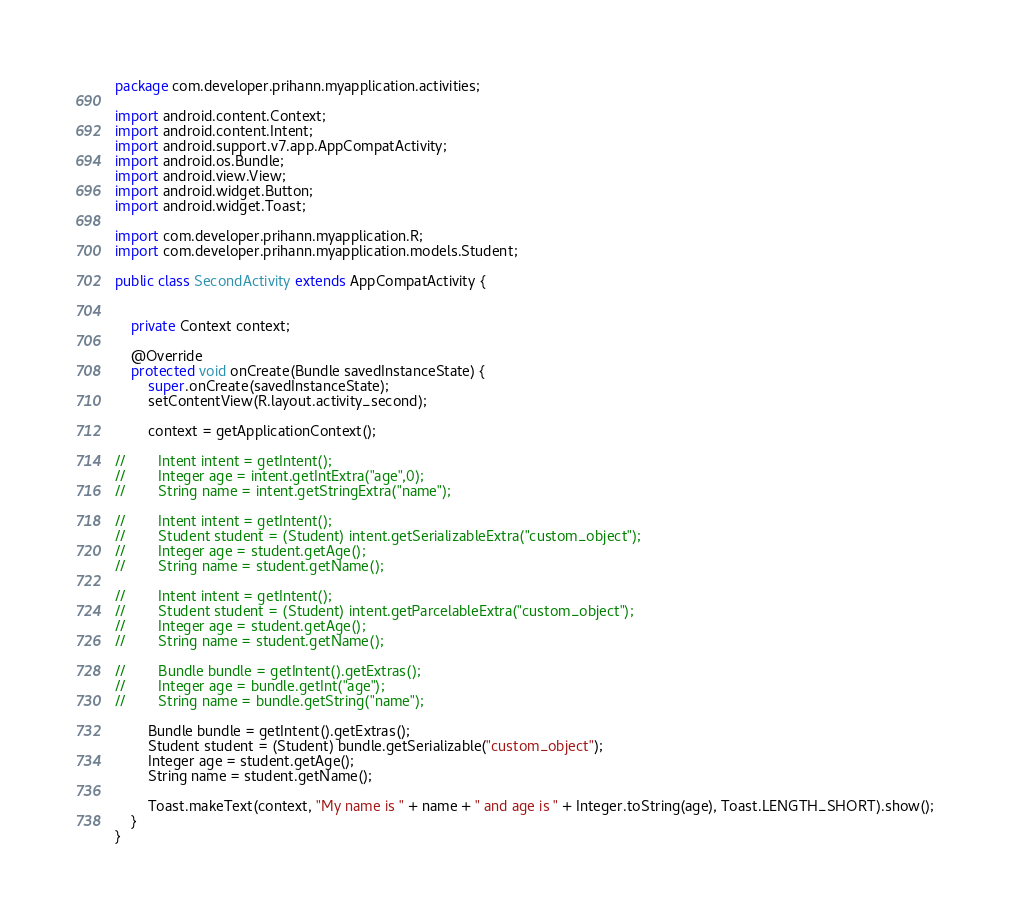Convert code to text. <code><loc_0><loc_0><loc_500><loc_500><_Java_>package com.developer.prihann.myapplication.activities;

import android.content.Context;
import android.content.Intent;
import android.support.v7.app.AppCompatActivity;
import android.os.Bundle;
import android.view.View;
import android.widget.Button;
import android.widget.Toast;

import com.developer.prihann.myapplication.R;
import com.developer.prihann.myapplication.models.Student;

public class SecondActivity extends AppCompatActivity {


    private Context context;

    @Override
    protected void onCreate(Bundle savedInstanceState) {
        super.onCreate(savedInstanceState);
        setContentView(R.layout.activity_second);

        context = getApplicationContext();

//        Intent intent = getIntent();
//        Integer age = intent.getIntExtra("age",0);
//        String name = intent.getStringExtra("name");

//        Intent intent = getIntent();
//        Student student = (Student) intent.getSerializableExtra("custom_object");
//        Integer age = student.getAge();
//        String name = student.getName();

//        Intent intent = getIntent();
//        Student student = (Student) intent.getParcelableExtra("custom_object");
//        Integer age = student.getAge();
//        String name = student.getName();

//        Bundle bundle = getIntent().getExtras();
//        Integer age = bundle.getInt("age");
//        String name = bundle.getString("name");

        Bundle bundle = getIntent().getExtras();
        Student student = (Student) bundle.getSerializable("custom_object");
        Integer age = student.getAge();
        String name = student.getName();

        Toast.makeText(context, "My name is " + name + " and age is " + Integer.toString(age), Toast.LENGTH_SHORT).show();
    }
}
</code> 